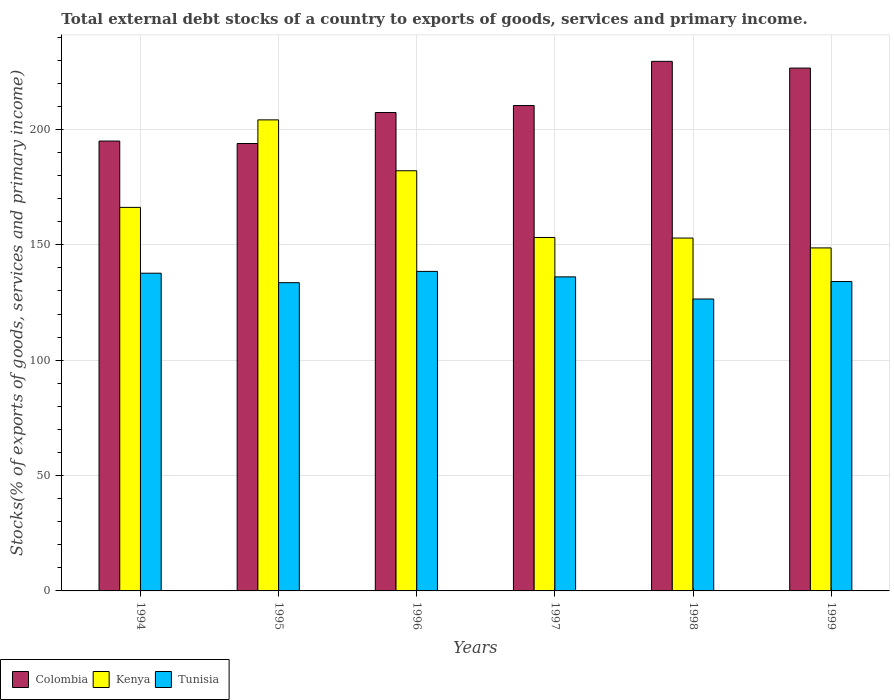Are the number of bars on each tick of the X-axis equal?
Offer a terse response. Yes. In how many cases, is the number of bars for a given year not equal to the number of legend labels?
Your answer should be very brief. 0. What is the total debt stocks in Kenya in 1996?
Give a very brief answer. 182.12. Across all years, what is the maximum total debt stocks in Colombia?
Your answer should be very brief. 229.54. Across all years, what is the minimum total debt stocks in Tunisia?
Give a very brief answer. 126.53. In which year was the total debt stocks in Colombia maximum?
Give a very brief answer. 1998. What is the total total debt stocks in Colombia in the graph?
Offer a terse response. 1262.83. What is the difference between the total debt stocks in Tunisia in 1995 and that in 1996?
Provide a succinct answer. -4.89. What is the difference between the total debt stocks in Kenya in 1998 and the total debt stocks in Tunisia in 1999?
Offer a very short reply. 18.85. What is the average total debt stocks in Colombia per year?
Provide a succinct answer. 210.47. In the year 1998, what is the difference between the total debt stocks in Kenya and total debt stocks in Colombia?
Your answer should be very brief. -76.59. What is the ratio of the total debt stocks in Colombia in 1994 to that in 1997?
Your answer should be very brief. 0.93. Is the total debt stocks in Kenya in 1994 less than that in 1996?
Your response must be concise. Yes. What is the difference between the highest and the second highest total debt stocks in Tunisia?
Keep it short and to the point. 0.78. What is the difference between the highest and the lowest total debt stocks in Kenya?
Give a very brief answer. 55.5. What does the 2nd bar from the right in 1994 represents?
Give a very brief answer. Kenya. Is it the case that in every year, the sum of the total debt stocks in Kenya and total debt stocks in Tunisia is greater than the total debt stocks in Colombia?
Ensure brevity in your answer.  Yes. Are all the bars in the graph horizontal?
Ensure brevity in your answer.  No. How many years are there in the graph?
Your response must be concise. 6. Are the values on the major ticks of Y-axis written in scientific E-notation?
Keep it short and to the point. No. What is the title of the graph?
Offer a terse response. Total external debt stocks of a country to exports of goods, services and primary income. Does "Djibouti" appear as one of the legend labels in the graph?
Provide a short and direct response. No. What is the label or title of the Y-axis?
Your response must be concise. Stocks(% of exports of goods, services and primary income). What is the Stocks(% of exports of goods, services and primary income) of Colombia in 1994?
Keep it short and to the point. 194.99. What is the Stocks(% of exports of goods, services and primary income) of Kenya in 1994?
Offer a very short reply. 166.24. What is the Stocks(% of exports of goods, services and primary income) of Tunisia in 1994?
Offer a terse response. 137.71. What is the Stocks(% of exports of goods, services and primary income) in Colombia in 1995?
Offer a terse response. 193.93. What is the Stocks(% of exports of goods, services and primary income) of Kenya in 1995?
Offer a very short reply. 204.17. What is the Stocks(% of exports of goods, services and primary income) in Tunisia in 1995?
Your response must be concise. 133.6. What is the Stocks(% of exports of goods, services and primary income) of Colombia in 1996?
Your answer should be very brief. 207.36. What is the Stocks(% of exports of goods, services and primary income) of Kenya in 1996?
Ensure brevity in your answer.  182.12. What is the Stocks(% of exports of goods, services and primary income) in Tunisia in 1996?
Offer a very short reply. 138.49. What is the Stocks(% of exports of goods, services and primary income) of Colombia in 1997?
Give a very brief answer. 210.38. What is the Stocks(% of exports of goods, services and primary income) of Kenya in 1997?
Offer a terse response. 153.19. What is the Stocks(% of exports of goods, services and primary income) in Tunisia in 1997?
Ensure brevity in your answer.  136.12. What is the Stocks(% of exports of goods, services and primary income) in Colombia in 1998?
Provide a short and direct response. 229.54. What is the Stocks(% of exports of goods, services and primary income) of Kenya in 1998?
Keep it short and to the point. 152.95. What is the Stocks(% of exports of goods, services and primary income) in Tunisia in 1998?
Make the answer very short. 126.53. What is the Stocks(% of exports of goods, services and primary income) in Colombia in 1999?
Your answer should be compact. 226.63. What is the Stocks(% of exports of goods, services and primary income) in Kenya in 1999?
Offer a terse response. 148.67. What is the Stocks(% of exports of goods, services and primary income) in Tunisia in 1999?
Your response must be concise. 134.1. Across all years, what is the maximum Stocks(% of exports of goods, services and primary income) in Colombia?
Offer a terse response. 229.54. Across all years, what is the maximum Stocks(% of exports of goods, services and primary income) of Kenya?
Give a very brief answer. 204.17. Across all years, what is the maximum Stocks(% of exports of goods, services and primary income) in Tunisia?
Ensure brevity in your answer.  138.49. Across all years, what is the minimum Stocks(% of exports of goods, services and primary income) in Colombia?
Your answer should be compact. 193.93. Across all years, what is the minimum Stocks(% of exports of goods, services and primary income) in Kenya?
Keep it short and to the point. 148.67. Across all years, what is the minimum Stocks(% of exports of goods, services and primary income) of Tunisia?
Give a very brief answer. 126.53. What is the total Stocks(% of exports of goods, services and primary income) in Colombia in the graph?
Your response must be concise. 1262.83. What is the total Stocks(% of exports of goods, services and primary income) in Kenya in the graph?
Your answer should be compact. 1007.35. What is the total Stocks(% of exports of goods, services and primary income) in Tunisia in the graph?
Your answer should be very brief. 806.55. What is the difference between the Stocks(% of exports of goods, services and primary income) in Colombia in 1994 and that in 1995?
Ensure brevity in your answer.  1.07. What is the difference between the Stocks(% of exports of goods, services and primary income) of Kenya in 1994 and that in 1995?
Your answer should be compact. -37.93. What is the difference between the Stocks(% of exports of goods, services and primary income) of Tunisia in 1994 and that in 1995?
Give a very brief answer. 4.11. What is the difference between the Stocks(% of exports of goods, services and primary income) in Colombia in 1994 and that in 1996?
Give a very brief answer. -12.37. What is the difference between the Stocks(% of exports of goods, services and primary income) of Kenya in 1994 and that in 1996?
Keep it short and to the point. -15.88. What is the difference between the Stocks(% of exports of goods, services and primary income) of Tunisia in 1994 and that in 1996?
Give a very brief answer. -0.78. What is the difference between the Stocks(% of exports of goods, services and primary income) in Colombia in 1994 and that in 1997?
Make the answer very short. -15.39. What is the difference between the Stocks(% of exports of goods, services and primary income) of Kenya in 1994 and that in 1997?
Keep it short and to the point. 13.05. What is the difference between the Stocks(% of exports of goods, services and primary income) of Tunisia in 1994 and that in 1997?
Keep it short and to the point. 1.59. What is the difference between the Stocks(% of exports of goods, services and primary income) in Colombia in 1994 and that in 1998?
Your answer should be compact. -34.54. What is the difference between the Stocks(% of exports of goods, services and primary income) of Kenya in 1994 and that in 1998?
Provide a short and direct response. 13.29. What is the difference between the Stocks(% of exports of goods, services and primary income) of Tunisia in 1994 and that in 1998?
Offer a terse response. 11.19. What is the difference between the Stocks(% of exports of goods, services and primary income) in Colombia in 1994 and that in 1999?
Make the answer very short. -31.63. What is the difference between the Stocks(% of exports of goods, services and primary income) in Kenya in 1994 and that in 1999?
Keep it short and to the point. 17.57. What is the difference between the Stocks(% of exports of goods, services and primary income) of Tunisia in 1994 and that in 1999?
Keep it short and to the point. 3.61. What is the difference between the Stocks(% of exports of goods, services and primary income) in Colombia in 1995 and that in 1996?
Keep it short and to the point. -13.44. What is the difference between the Stocks(% of exports of goods, services and primary income) of Kenya in 1995 and that in 1996?
Offer a very short reply. 22.05. What is the difference between the Stocks(% of exports of goods, services and primary income) of Tunisia in 1995 and that in 1996?
Ensure brevity in your answer.  -4.89. What is the difference between the Stocks(% of exports of goods, services and primary income) in Colombia in 1995 and that in 1997?
Your answer should be compact. -16.46. What is the difference between the Stocks(% of exports of goods, services and primary income) in Kenya in 1995 and that in 1997?
Your answer should be very brief. 50.98. What is the difference between the Stocks(% of exports of goods, services and primary income) in Tunisia in 1995 and that in 1997?
Your answer should be compact. -2.52. What is the difference between the Stocks(% of exports of goods, services and primary income) of Colombia in 1995 and that in 1998?
Your answer should be compact. -35.61. What is the difference between the Stocks(% of exports of goods, services and primary income) of Kenya in 1995 and that in 1998?
Give a very brief answer. 51.22. What is the difference between the Stocks(% of exports of goods, services and primary income) in Tunisia in 1995 and that in 1998?
Your answer should be compact. 7.08. What is the difference between the Stocks(% of exports of goods, services and primary income) in Colombia in 1995 and that in 1999?
Keep it short and to the point. -32.7. What is the difference between the Stocks(% of exports of goods, services and primary income) in Kenya in 1995 and that in 1999?
Your answer should be very brief. 55.5. What is the difference between the Stocks(% of exports of goods, services and primary income) of Tunisia in 1995 and that in 1999?
Your answer should be compact. -0.5. What is the difference between the Stocks(% of exports of goods, services and primary income) in Colombia in 1996 and that in 1997?
Keep it short and to the point. -3.02. What is the difference between the Stocks(% of exports of goods, services and primary income) in Kenya in 1996 and that in 1997?
Your answer should be very brief. 28.92. What is the difference between the Stocks(% of exports of goods, services and primary income) of Tunisia in 1996 and that in 1997?
Provide a short and direct response. 2.37. What is the difference between the Stocks(% of exports of goods, services and primary income) in Colombia in 1996 and that in 1998?
Provide a short and direct response. -22.17. What is the difference between the Stocks(% of exports of goods, services and primary income) of Kenya in 1996 and that in 1998?
Keep it short and to the point. 29.17. What is the difference between the Stocks(% of exports of goods, services and primary income) in Tunisia in 1996 and that in 1998?
Your response must be concise. 11.97. What is the difference between the Stocks(% of exports of goods, services and primary income) in Colombia in 1996 and that in 1999?
Provide a short and direct response. -19.26. What is the difference between the Stocks(% of exports of goods, services and primary income) in Kenya in 1996 and that in 1999?
Provide a short and direct response. 33.44. What is the difference between the Stocks(% of exports of goods, services and primary income) of Tunisia in 1996 and that in 1999?
Keep it short and to the point. 4.39. What is the difference between the Stocks(% of exports of goods, services and primary income) of Colombia in 1997 and that in 1998?
Your answer should be very brief. -19.15. What is the difference between the Stocks(% of exports of goods, services and primary income) in Kenya in 1997 and that in 1998?
Ensure brevity in your answer.  0.25. What is the difference between the Stocks(% of exports of goods, services and primary income) of Tunisia in 1997 and that in 1998?
Make the answer very short. 9.6. What is the difference between the Stocks(% of exports of goods, services and primary income) in Colombia in 1997 and that in 1999?
Your answer should be compact. -16.24. What is the difference between the Stocks(% of exports of goods, services and primary income) in Kenya in 1997 and that in 1999?
Offer a very short reply. 4.52. What is the difference between the Stocks(% of exports of goods, services and primary income) of Tunisia in 1997 and that in 1999?
Offer a terse response. 2.02. What is the difference between the Stocks(% of exports of goods, services and primary income) of Colombia in 1998 and that in 1999?
Your answer should be very brief. 2.91. What is the difference between the Stocks(% of exports of goods, services and primary income) in Kenya in 1998 and that in 1999?
Keep it short and to the point. 4.27. What is the difference between the Stocks(% of exports of goods, services and primary income) of Tunisia in 1998 and that in 1999?
Give a very brief answer. -7.58. What is the difference between the Stocks(% of exports of goods, services and primary income) in Colombia in 1994 and the Stocks(% of exports of goods, services and primary income) in Kenya in 1995?
Your response must be concise. -9.18. What is the difference between the Stocks(% of exports of goods, services and primary income) of Colombia in 1994 and the Stocks(% of exports of goods, services and primary income) of Tunisia in 1995?
Give a very brief answer. 61.39. What is the difference between the Stocks(% of exports of goods, services and primary income) in Kenya in 1994 and the Stocks(% of exports of goods, services and primary income) in Tunisia in 1995?
Your answer should be very brief. 32.64. What is the difference between the Stocks(% of exports of goods, services and primary income) in Colombia in 1994 and the Stocks(% of exports of goods, services and primary income) in Kenya in 1996?
Provide a short and direct response. 12.87. What is the difference between the Stocks(% of exports of goods, services and primary income) of Colombia in 1994 and the Stocks(% of exports of goods, services and primary income) of Tunisia in 1996?
Provide a short and direct response. 56.5. What is the difference between the Stocks(% of exports of goods, services and primary income) of Kenya in 1994 and the Stocks(% of exports of goods, services and primary income) of Tunisia in 1996?
Your response must be concise. 27.75. What is the difference between the Stocks(% of exports of goods, services and primary income) in Colombia in 1994 and the Stocks(% of exports of goods, services and primary income) in Kenya in 1997?
Your response must be concise. 41.8. What is the difference between the Stocks(% of exports of goods, services and primary income) in Colombia in 1994 and the Stocks(% of exports of goods, services and primary income) in Tunisia in 1997?
Your answer should be very brief. 58.87. What is the difference between the Stocks(% of exports of goods, services and primary income) of Kenya in 1994 and the Stocks(% of exports of goods, services and primary income) of Tunisia in 1997?
Offer a very short reply. 30.12. What is the difference between the Stocks(% of exports of goods, services and primary income) of Colombia in 1994 and the Stocks(% of exports of goods, services and primary income) of Kenya in 1998?
Your response must be concise. 42.04. What is the difference between the Stocks(% of exports of goods, services and primary income) of Colombia in 1994 and the Stocks(% of exports of goods, services and primary income) of Tunisia in 1998?
Your answer should be very brief. 68.47. What is the difference between the Stocks(% of exports of goods, services and primary income) of Kenya in 1994 and the Stocks(% of exports of goods, services and primary income) of Tunisia in 1998?
Your response must be concise. 39.71. What is the difference between the Stocks(% of exports of goods, services and primary income) of Colombia in 1994 and the Stocks(% of exports of goods, services and primary income) of Kenya in 1999?
Keep it short and to the point. 46.32. What is the difference between the Stocks(% of exports of goods, services and primary income) in Colombia in 1994 and the Stocks(% of exports of goods, services and primary income) in Tunisia in 1999?
Make the answer very short. 60.89. What is the difference between the Stocks(% of exports of goods, services and primary income) of Kenya in 1994 and the Stocks(% of exports of goods, services and primary income) of Tunisia in 1999?
Your response must be concise. 32.14. What is the difference between the Stocks(% of exports of goods, services and primary income) of Colombia in 1995 and the Stocks(% of exports of goods, services and primary income) of Kenya in 1996?
Offer a terse response. 11.81. What is the difference between the Stocks(% of exports of goods, services and primary income) of Colombia in 1995 and the Stocks(% of exports of goods, services and primary income) of Tunisia in 1996?
Provide a succinct answer. 55.44. What is the difference between the Stocks(% of exports of goods, services and primary income) of Kenya in 1995 and the Stocks(% of exports of goods, services and primary income) of Tunisia in 1996?
Make the answer very short. 65.68. What is the difference between the Stocks(% of exports of goods, services and primary income) of Colombia in 1995 and the Stocks(% of exports of goods, services and primary income) of Kenya in 1997?
Provide a succinct answer. 40.73. What is the difference between the Stocks(% of exports of goods, services and primary income) of Colombia in 1995 and the Stocks(% of exports of goods, services and primary income) of Tunisia in 1997?
Offer a very short reply. 57.8. What is the difference between the Stocks(% of exports of goods, services and primary income) of Kenya in 1995 and the Stocks(% of exports of goods, services and primary income) of Tunisia in 1997?
Offer a very short reply. 68.05. What is the difference between the Stocks(% of exports of goods, services and primary income) in Colombia in 1995 and the Stocks(% of exports of goods, services and primary income) in Kenya in 1998?
Give a very brief answer. 40.98. What is the difference between the Stocks(% of exports of goods, services and primary income) of Colombia in 1995 and the Stocks(% of exports of goods, services and primary income) of Tunisia in 1998?
Your response must be concise. 67.4. What is the difference between the Stocks(% of exports of goods, services and primary income) in Kenya in 1995 and the Stocks(% of exports of goods, services and primary income) in Tunisia in 1998?
Provide a short and direct response. 77.65. What is the difference between the Stocks(% of exports of goods, services and primary income) of Colombia in 1995 and the Stocks(% of exports of goods, services and primary income) of Kenya in 1999?
Provide a short and direct response. 45.25. What is the difference between the Stocks(% of exports of goods, services and primary income) in Colombia in 1995 and the Stocks(% of exports of goods, services and primary income) in Tunisia in 1999?
Provide a succinct answer. 59.82. What is the difference between the Stocks(% of exports of goods, services and primary income) in Kenya in 1995 and the Stocks(% of exports of goods, services and primary income) in Tunisia in 1999?
Offer a very short reply. 70.07. What is the difference between the Stocks(% of exports of goods, services and primary income) in Colombia in 1996 and the Stocks(% of exports of goods, services and primary income) in Kenya in 1997?
Keep it short and to the point. 54.17. What is the difference between the Stocks(% of exports of goods, services and primary income) in Colombia in 1996 and the Stocks(% of exports of goods, services and primary income) in Tunisia in 1997?
Offer a terse response. 71.24. What is the difference between the Stocks(% of exports of goods, services and primary income) in Kenya in 1996 and the Stocks(% of exports of goods, services and primary income) in Tunisia in 1997?
Make the answer very short. 45.99. What is the difference between the Stocks(% of exports of goods, services and primary income) in Colombia in 1996 and the Stocks(% of exports of goods, services and primary income) in Kenya in 1998?
Keep it short and to the point. 54.41. What is the difference between the Stocks(% of exports of goods, services and primary income) of Colombia in 1996 and the Stocks(% of exports of goods, services and primary income) of Tunisia in 1998?
Ensure brevity in your answer.  80.84. What is the difference between the Stocks(% of exports of goods, services and primary income) of Kenya in 1996 and the Stocks(% of exports of goods, services and primary income) of Tunisia in 1998?
Provide a succinct answer. 55.59. What is the difference between the Stocks(% of exports of goods, services and primary income) of Colombia in 1996 and the Stocks(% of exports of goods, services and primary income) of Kenya in 1999?
Make the answer very short. 58.69. What is the difference between the Stocks(% of exports of goods, services and primary income) of Colombia in 1996 and the Stocks(% of exports of goods, services and primary income) of Tunisia in 1999?
Provide a short and direct response. 73.26. What is the difference between the Stocks(% of exports of goods, services and primary income) of Kenya in 1996 and the Stocks(% of exports of goods, services and primary income) of Tunisia in 1999?
Your response must be concise. 48.01. What is the difference between the Stocks(% of exports of goods, services and primary income) in Colombia in 1997 and the Stocks(% of exports of goods, services and primary income) in Kenya in 1998?
Offer a terse response. 57.43. What is the difference between the Stocks(% of exports of goods, services and primary income) of Colombia in 1997 and the Stocks(% of exports of goods, services and primary income) of Tunisia in 1998?
Your response must be concise. 83.86. What is the difference between the Stocks(% of exports of goods, services and primary income) in Kenya in 1997 and the Stocks(% of exports of goods, services and primary income) in Tunisia in 1998?
Keep it short and to the point. 26.67. What is the difference between the Stocks(% of exports of goods, services and primary income) in Colombia in 1997 and the Stocks(% of exports of goods, services and primary income) in Kenya in 1999?
Provide a short and direct response. 61.71. What is the difference between the Stocks(% of exports of goods, services and primary income) in Colombia in 1997 and the Stocks(% of exports of goods, services and primary income) in Tunisia in 1999?
Provide a succinct answer. 76.28. What is the difference between the Stocks(% of exports of goods, services and primary income) of Kenya in 1997 and the Stocks(% of exports of goods, services and primary income) of Tunisia in 1999?
Keep it short and to the point. 19.09. What is the difference between the Stocks(% of exports of goods, services and primary income) in Colombia in 1998 and the Stocks(% of exports of goods, services and primary income) in Kenya in 1999?
Ensure brevity in your answer.  80.86. What is the difference between the Stocks(% of exports of goods, services and primary income) in Colombia in 1998 and the Stocks(% of exports of goods, services and primary income) in Tunisia in 1999?
Offer a terse response. 95.43. What is the difference between the Stocks(% of exports of goods, services and primary income) in Kenya in 1998 and the Stocks(% of exports of goods, services and primary income) in Tunisia in 1999?
Your answer should be compact. 18.84. What is the average Stocks(% of exports of goods, services and primary income) in Colombia per year?
Your answer should be very brief. 210.47. What is the average Stocks(% of exports of goods, services and primary income) of Kenya per year?
Provide a short and direct response. 167.89. What is the average Stocks(% of exports of goods, services and primary income) of Tunisia per year?
Keep it short and to the point. 134.43. In the year 1994, what is the difference between the Stocks(% of exports of goods, services and primary income) of Colombia and Stocks(% of exports of goods, services and primary income) of Kenya?
Your response must be concise. 28.75. In the year 1994, what is the difference between the Stocks(% of exports of goods, services and primary income) in Colombia and Stocks(% of exports of goods, services and primary income) in Tunisia?
Ensure brevity in your answer.  57.28. In the year 1994, what is the difference between the Stocks(% of exports of goods, services and primary income) of Kenya and Stocks(% of exports of goods, services and primary income) of Tunisia?
Your response must be concise. 28.53. In the year 1995, what is the difference between the Stocks(% of exports of goods, services and primary income) in Colombia and Stocks(% of exports of goods, services and primary income) in Kenya?
Your response must be concise. -10.25. In the year 1995, what is the difference between the Stocks(% of exports of goods, services and primary income) of Colombia and Stocks(% of exports of goods, services and primary income) of Tunisia?
Offer a terse response. 60.32. In the year 1995, what is the difference between the Stocks(% of exports of goods, services and primary income) in Kenya and Stocks(% of exports of goods, services and primary income) in Tunisia?
Ensure brevity in your answer.  70.57. In the year 1996, what is the difference between the Stocks(% of exports of goods, services and primary income) in Colombia and Stocks(% of exports of goods, services and primary income) in Kenya?
Your response must be concise. 25.25. In the year 1996, what is the difference between the Stocks(% of exports of goods, services and primary income) of Colombia and Stocks(% of exports of goods, services and primary income) of Tunisia?
Offer a terse response. 68.87. In the year 1996, what is the difference between the Stocks(% of exports of goods, services and primary income) of Kenya and Stocks(% of exports of goods, services and primary income) of Tunisia?
Give a very brief answer. 43.63. In the year 1997, what is the difference between the Stocks(% of exports of goods, services and primary income) in Colombia and Stocks(% of exports of goods, services and primary income) in Kenya?
Give a very brief answer. 57.19. In the year 1997, what is the difference between the Stocks(% of exports of goods, services and primary income) in Colombia and Stocks(% of exports of goods, services and primary income) in Tunisia?
Offer a very short reply. 74.26. In the year 1997, what is the difference between the Stocks(% of exports of goods, services and primary income) in Kenya and Stocks(% of exports of goods, services and primary income) in Tunisia?
Provide a succinct answer. 17.07. In the year 1998, what is the difference between the Stocks(% of exports of goods, services and primary income) in Colombia and Stocks(% of exports of goods, services and primary income) in Kenya?
Your answer should be compact. 76.59. In the year 1998, what is the difference between the Stocks(% of exports of goods, services and primary income) of Colombia and Stocks(% of exports of goods, services and primary income) of Tunisia?
Provide a short and direct response. 103.01. In the year 1998, what is the difference between the Stocks(% of exports of goods, services and primary income) in Kenya and Stocks(% of exports of goods, services and primary income) in Tunisia?
Offer a terse response. 26.42. In the year 1999, what is the difference between the Stocks(% of exports of goods, services and primary income) in Colombia and Stocks(% of exports of goods, services and primary income) in Kenya?
Provide a succinct answer. 77.95. In the year 1999, what is the difference between the Stocks(% of exports of goods, services and primary income) in Colombia and Stocks(% of exports of goods, services and primary income) in Tunisia?
Provide a succinct answer. 92.52. In the year 1999, what is the difference between the Stocks(% of exports of goods, services and primary income) of Kenya and Stocks(% of exports of goods, services and primary income) of Tunisia?
Your answer should be very brief. 14.57. What is the ratio of the Stocks(% of exports of goods, services and primary income) in Colombia in 1994 to that in 1995?
Keep it short and to the point. 1.01. What is the ratio of the Stocks(% of exports of goods, services and primary income) in Kenya in 1994 to that in 1995?
Offer a terse response. 0.81. What is the ratio of the Stocks(% of exports of goods, services and primary income) of Tunisia in 1994 to that in 1995?
Keep it short and to the point. 1.03. What is the ratio of the Stocks(% of exports of goods, services and primary income) of Colombia in 1994 to that in 1996?
Your response must be concise. 0.94. What is the ratio of the Stocks(% of exports of goods, services and primary income) in Kenya in 1994 to that in 1996?
Ensure brevity in your answer.  0.91. What is the ratio of the Stocks(% of exports of goods, services and primary income) of Tunisia in 1994 to that in 1996?
Give a very brief answer. 0.99. What is the ratio of the Stocks(% of exports of goods, services and primary income) of Colombia in 1994 to that in 1997?
Your response must be concise. 0.93. What is the ratio of the Stocks(% of exports of goods, services and primary income) of Kenya in 1994 to that in 1997?
Your answer should be compact. 1.09. What is the ratio of the Stocks(% of exports of goods, services and primary income) of Tunisia in 1994 to that in 1997?
Keep it short and to the point. 1.01. What is the ratio of the Stocks(% of exports of goods, services and primary income) of Colombia in 1994 to that in 1998?
Offer a terse response. 0.85. What is the ratio of the Stocks(% of exports of goods, services and primary income) in Kenya in 1994 to that in 1998?
Keep it short and to the point. 1.09. What is the ratio of the Stocks(% of exports of goods, services and primary income) of Tunisia in 1994 to that in 1998?
Offer a very short reply. 1.09. What is the ratio of the Stocks(% of exports of goods, services and primary income) of Colombia in 1994 to that in 1999?
Your answer should be compact. 0.86. What is the ratio of the Stocks(% of exports of goods, services and primary income) in Kenya in 1994 to that in 1999?
Keep it short and to the point. 1.12. What is the ratio of the Stocks(% of exports of goods, services and primary income) in Tunisia in 1994 to that in 1999?
Your answer should be compact. 1.03. What is the ratio of the Stocks(% of exports of goods, services and primary income) of Colombia in 1995 to that in 1996?
Ensure brevity in your answer.  0.94. What is the ratio of the Stocks(% of exports of goods, services and primary income) in Kenya in 1995 to that in 1996?
Give a very brief answer. 1.12. What is the ratio of the Stocks(% of exports of goods, services and primary income) in Tunisia in 1995 to that in 1996?
Provide a succinct answer. 0.96. What is the ratio of the Stocks(% of exports of goods, services and primary income) of Colombia in 1995 to that in 1997?
Make the answer very short. 0.92. What is the ratio of the Stocks(% of exports of goods, services and primary income) of Kenya in 1995 to that in 1997?
Ensure brevity in your answer.  1.33. What is the ratio of the Stocks(% of exports of goods, services and primary income) in Tunisia in 1995 to that in 1997?
Provide a succinct answer. 0.98. What is the ratio of the Stocks(% of exports of goods, services and primary income) in Colombia in 1995 to that in 1998?
Your answer should be very brief. 0.84. What is the ratio of the Stocks(% of exports of goods, services and primary income) of Kenya in 1995 to that in 1998?
Your response must be concise. 1.33. What is the ratio of the Stocks(% of exports of goods, services and primary income) in Tunisia in 1995 to that in 1998?
Offer a very short reply. 1.06. What is the ratio of the Stocks(% of exports of goods, services and primary income) in Colombia in 1995 to that in 1999?
Provide a succinct answer. 0.86. What is the ratio of the Stocks(% of exports of goods, services and primary income) of Kenya in 1995 to that in 1999?
Keep it short and to the point. 1.37. What is the ratio of the Stocks(% of exports of goods, services and primary income) of Tunisia in 1995 to that in 1999?
Offer a terse response. 1. What is the ratio of the Stocks(% of exports of goods, services and primary income) of Colombia in 1996 to that in 1997?
Keep it short and to the point. 0.99. What is the ratio of the Stocks(% of exports of goods, services and primary income) in Kenya in 1996 to that in 1997?
Your answer should be compact. 1.19. What is the ratio of the Stocks(% of exports of goods, services and primary income) in Tunisia in 1996 to that in 1997?
Offer a terse response. 1.02. What is the ratio of the Stocks(% of exports of goods, services and primary income) of Colombia in 1996 to that in 1998?
Provide a succinct answer. 0.9. What is the ratio of the Stocks(% of exports of goods, services and primary income) in Kenya in 1996 to that in 1998?
Your answer should be compact. 1.19. What is the ratio of the Stocks(% of exports of goods, services and primary income) of Tunisia in 1996 to that in 1998?
Give a very brief answer. 1.09. What is the ratio of the Stocks(% of exports of goods, services and primary income) of Colombia in 1996 to that in 1999?
Make the answer very short. 0.92. What is the ratio of the Stocks(% of exports of goods, services and primary income) of Kenya in 1996 to that in 1999?
Provide a short and direct response. 1.22. What is the ratio of the Stocks(% of exports of goods, services and primary income) of Tunisia in 1996 to that in 1999?
Offer a very short reply. 1.03. What is the ratio of the Stocks(% of exports of goods, services and primary income) of Colombia in 1997 to that in 1998?
Make the answer very short. 0.92. What is the ratio of the Stocks(% of exports of goods, services and primary income) of Kenya in 1997 to that in 1998?
Give a very brief answer. 1. What is the ratio of the Stocks(% of exports of goods, services and primary income) in Tunisia in 1997 to that in 1998?
Ensure brevity in your answer.  1.08. What is the ratio of the Stocks(% of exports of goods, services and primary income) of Colombia in 1997 to that in 1999?
Offer a very short reply. 0.93. What is the ratio of the Stocks(% of exports of goods, services and primary income) in Kenya in 1997 to that in 1999?
Provide a succinct answer. 1.03. What is the ratio of the Stocks(% of exports of goods, services and primary income) of Tunisia in 1997 to that in 1999?
Provide a short and direct response. 1.02. What is the ratio of the Stocks(% of exports of goods, services and primary income) of Colombia in 1998 to that in 1999?
Your answer should be compact. 1.01. What is the ratio of the Stocks(% of exports of goods, services and primary income) in Kenya in 1998 to that in 1999?
Provide a short and direct response. 1.03. What is the ratio of the Stocks(% of exports of goods, services and primary income) of Tunisia in 1998 to that in 1999?
Make the answer very short. 0.94. What is the difference between the highest and the second highest Stocks(% of exports of goods, services and primary income) in Colombia?
Offer a terse response. 2.91. What is the difference between the highest and the second highest Stocks(% of exports of goods, services and primary income) in Kenya?
Offer a terse response. 22.05. What is the difference between the highest and the second highest Stocks(% of exports of goods, services and primary income) in Tunisia?
Your answer should be very brief. 0.78. What is the difference between the highest and the lowest Stocks(% of exports of goods, services and primary income) of Colombia?
Your answer should be very brief. 35.61. What is the difference between the highest and the lowest Stocks(% of exports of goods, services and primary income) of Kenya?
Provide a succinct answer. 55.5. What is the difference between the highest and the lowest Stocks(% of exports of goods, services and primary income) in Tunisia?
Provide a short and direct response. 11.97. 